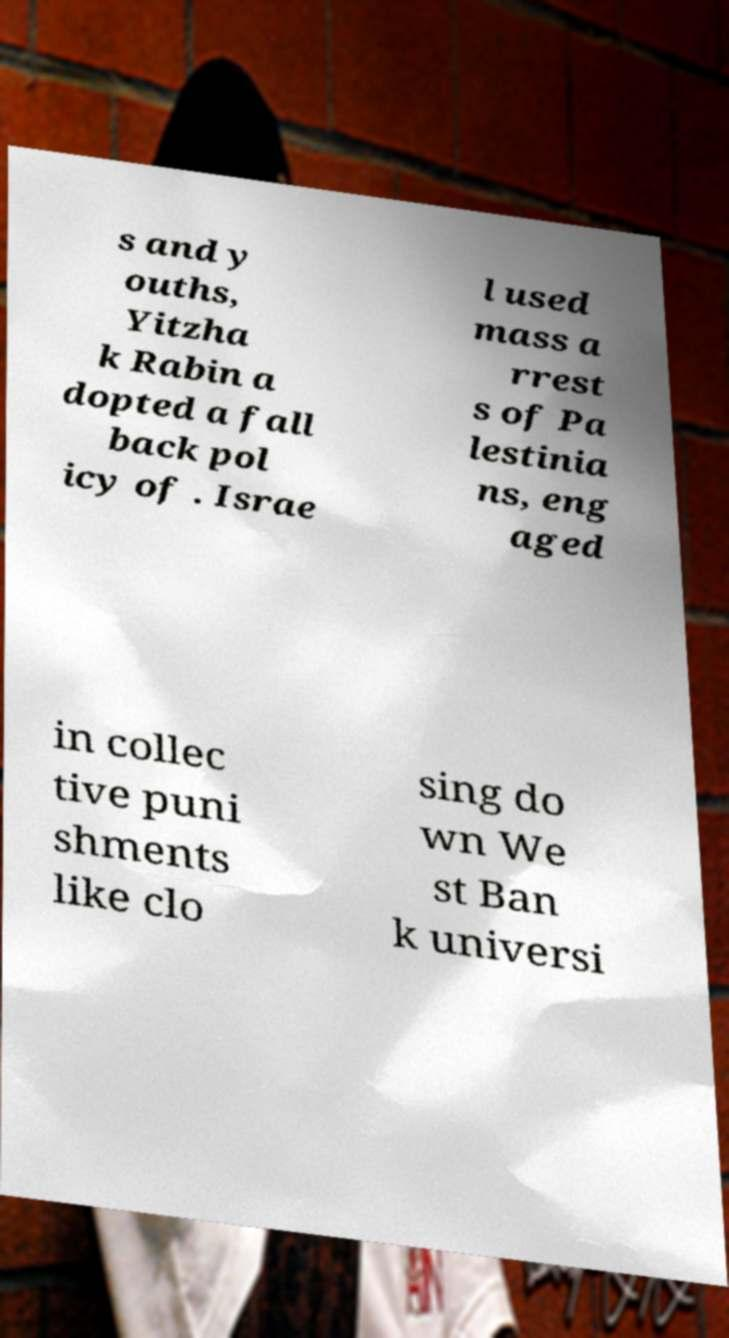There's text embedded in this image that I need extracted. Can you transcribe it verbatim? s and y ouths, Yitzha k Rabin a dopted a fall back pol icy of . Israe l used mass a rrest s of Pa lestinia ns, eng aged in collec tive puni shments like clo sing do wn We st Ban k universi 